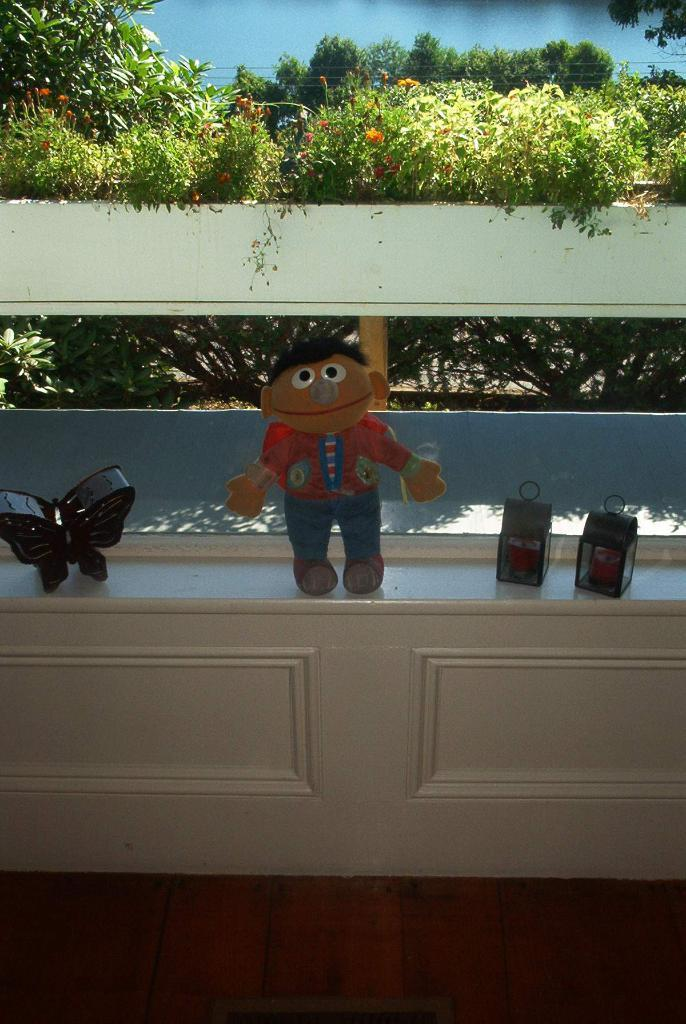What type of toy is visible in the image? There is a toy in the image, but the specific type cannot be determined from the provided facts. What is the butterfly box used for? The butterfly box is likely used for housing or displaying butterflies, but the exact purpose cannot be determined from the provided facts. What other objects are present on the wooden board? There are other objects on the wooden board, but their specific nature cannot be determined from the provided facts. What type of trees are visible in the image? The trees visible in the image have branches and leaves, but their specific type cannot be determined from the provided facts. How does the parent help the child in the image? There is no child or parent present in the image, so it is not possible to answer this question. 